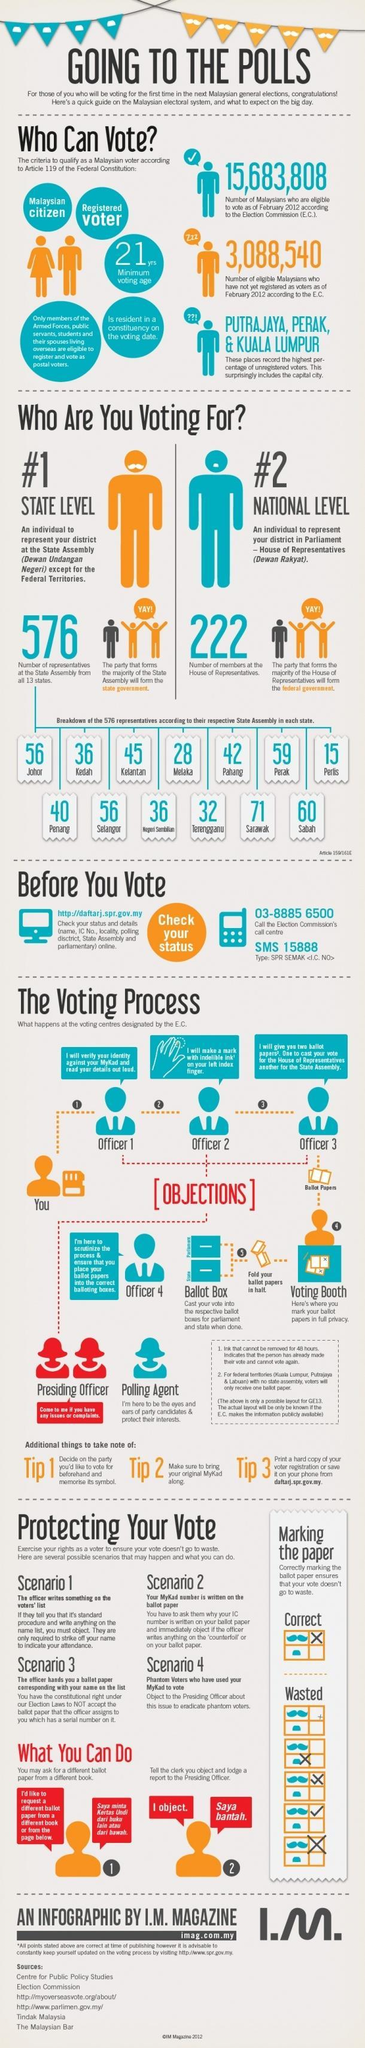How many total citizens are qualified to vote?
Answer the question with a short phrase. 15,683,808 Which state has the highest number of representatives in the State Assembly? Sarawak What does the party with majority in State Assembly form? the state government What does the party with majority in House of Representatives form? the federal government During the voting process, who can be approached if you have any issues or complaints? Presiding Officer From which state are there 28 representatives in the State Assembly? Melaka Which state has the lowest number of representatives in the State Assembly? Perlis How many of the eligible citizens are unregistered as voters? 3,088,540 How many representatives from Kedah in the State Assembly? 36 How many members at the House of Representatives? 222 